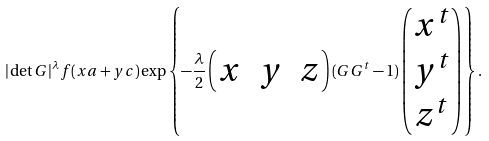<formula> <loc_0><loc_0><loc_500><loc_500>| \det G | ^ { \lambda } f ( x a + y c ) \exp \left \{ - \frac { \lambda } { 2 } \begin{pmatrix} x & y & z \end{pmatrix} ( G G ^ { t } - 1 ) \begin{pmatrix} x ^ { t } \\ y ^ { t } \\ z ^ { t } \end{pmatrix} \right \} .</formula> 